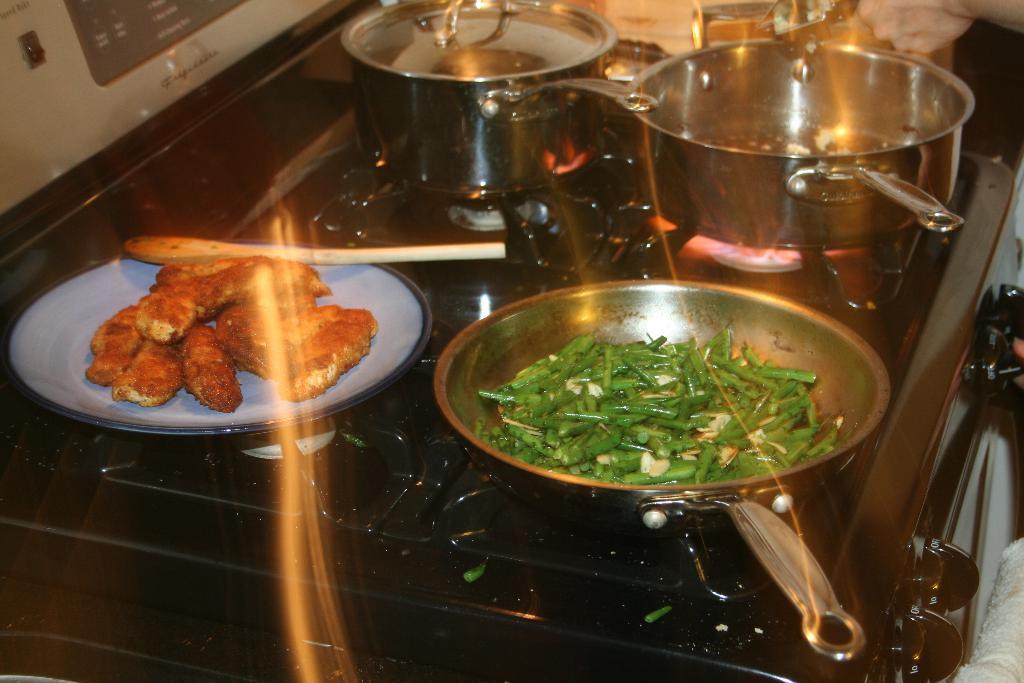Please provide a concise description of this image. In the picture there is a stove, there are bowls and a plate with the food item present, there is a hand of a person present. 